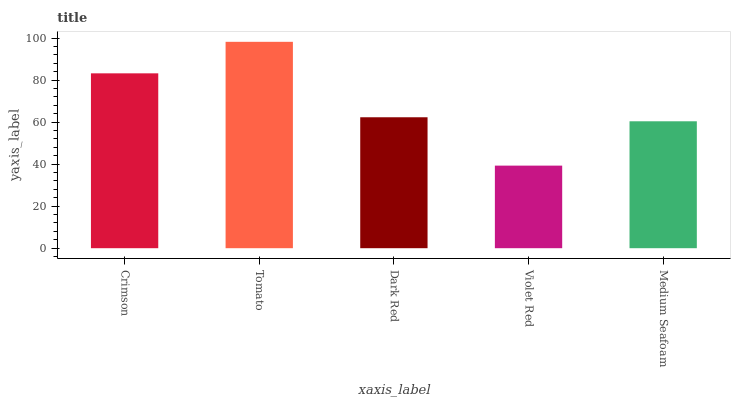Is Violet Red the minimum?
Answer yes or no. Yes. Is Tomato the maximum?
Answer yes or no. Yes. Is Dark Red the minimum?
Answer yes or no. No. Is Dark Red the maximum?
Answer yes or no. No. Is Tomato greater than Dark Red?
Answer yes or no. Yes. Is Dark Red less than Tomato?
Answer yes or no. Yes. Is Dark Red greater than Tomato?
Answer yes or no. No. Is Tomato less than Dark Red?
Answer yes or no. No. Is Dark Red the high median?
Answer yes or no. Yes. Is Dark Red the low median?
Answer yes or no. Yes. Is Tomato the high median?
Answer yes or no. No. Is Crimson the low median?
Answer yes or no. No. 